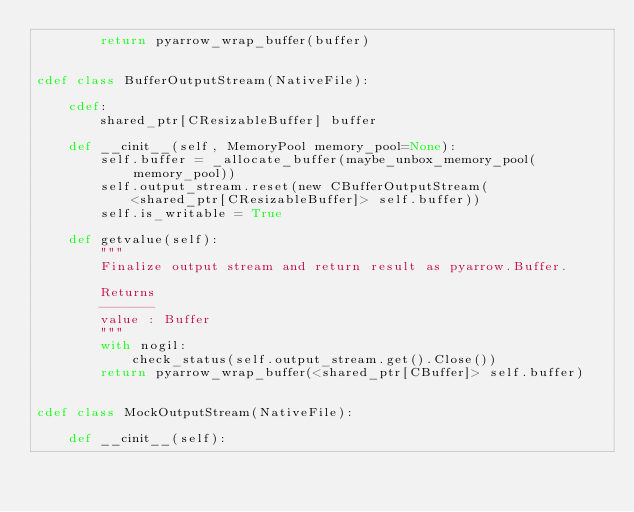<code> <loc_0><loc_0><loc_500><loc_500><_Cython_>        return pyarrow_wrap_buffer(buffer)


cdef class BufferOutputStream(NativeFile):

    cdef:
        shared_ptr[CResizableBuffer] buffer

    def __cinit__(self, MemoryPool memory_pool=None):
        self.buffer = _allocate_buffer(maybe_unbox_memory_pool(memory_pool))
        self.output_stream.reset(new CBufferOutputStream(
            <shared_ptr[CResizableBuffer]> self.buffer))
        self.is_writable = True

    def getvalue(self):
        """
        Finalize output stream and return result as pyarrow.Buffer.

        Returns
        -------
        value : Buffer
        """
        with nogil:
            check_status(self.output_stream.get().Close())
        return pyarrow_wrap_buffer(<shared_ptr[CBuffer]> self.buffer)


cdef class MockOutputStream(NativeFile):

    def __cinit__(self):</code> 